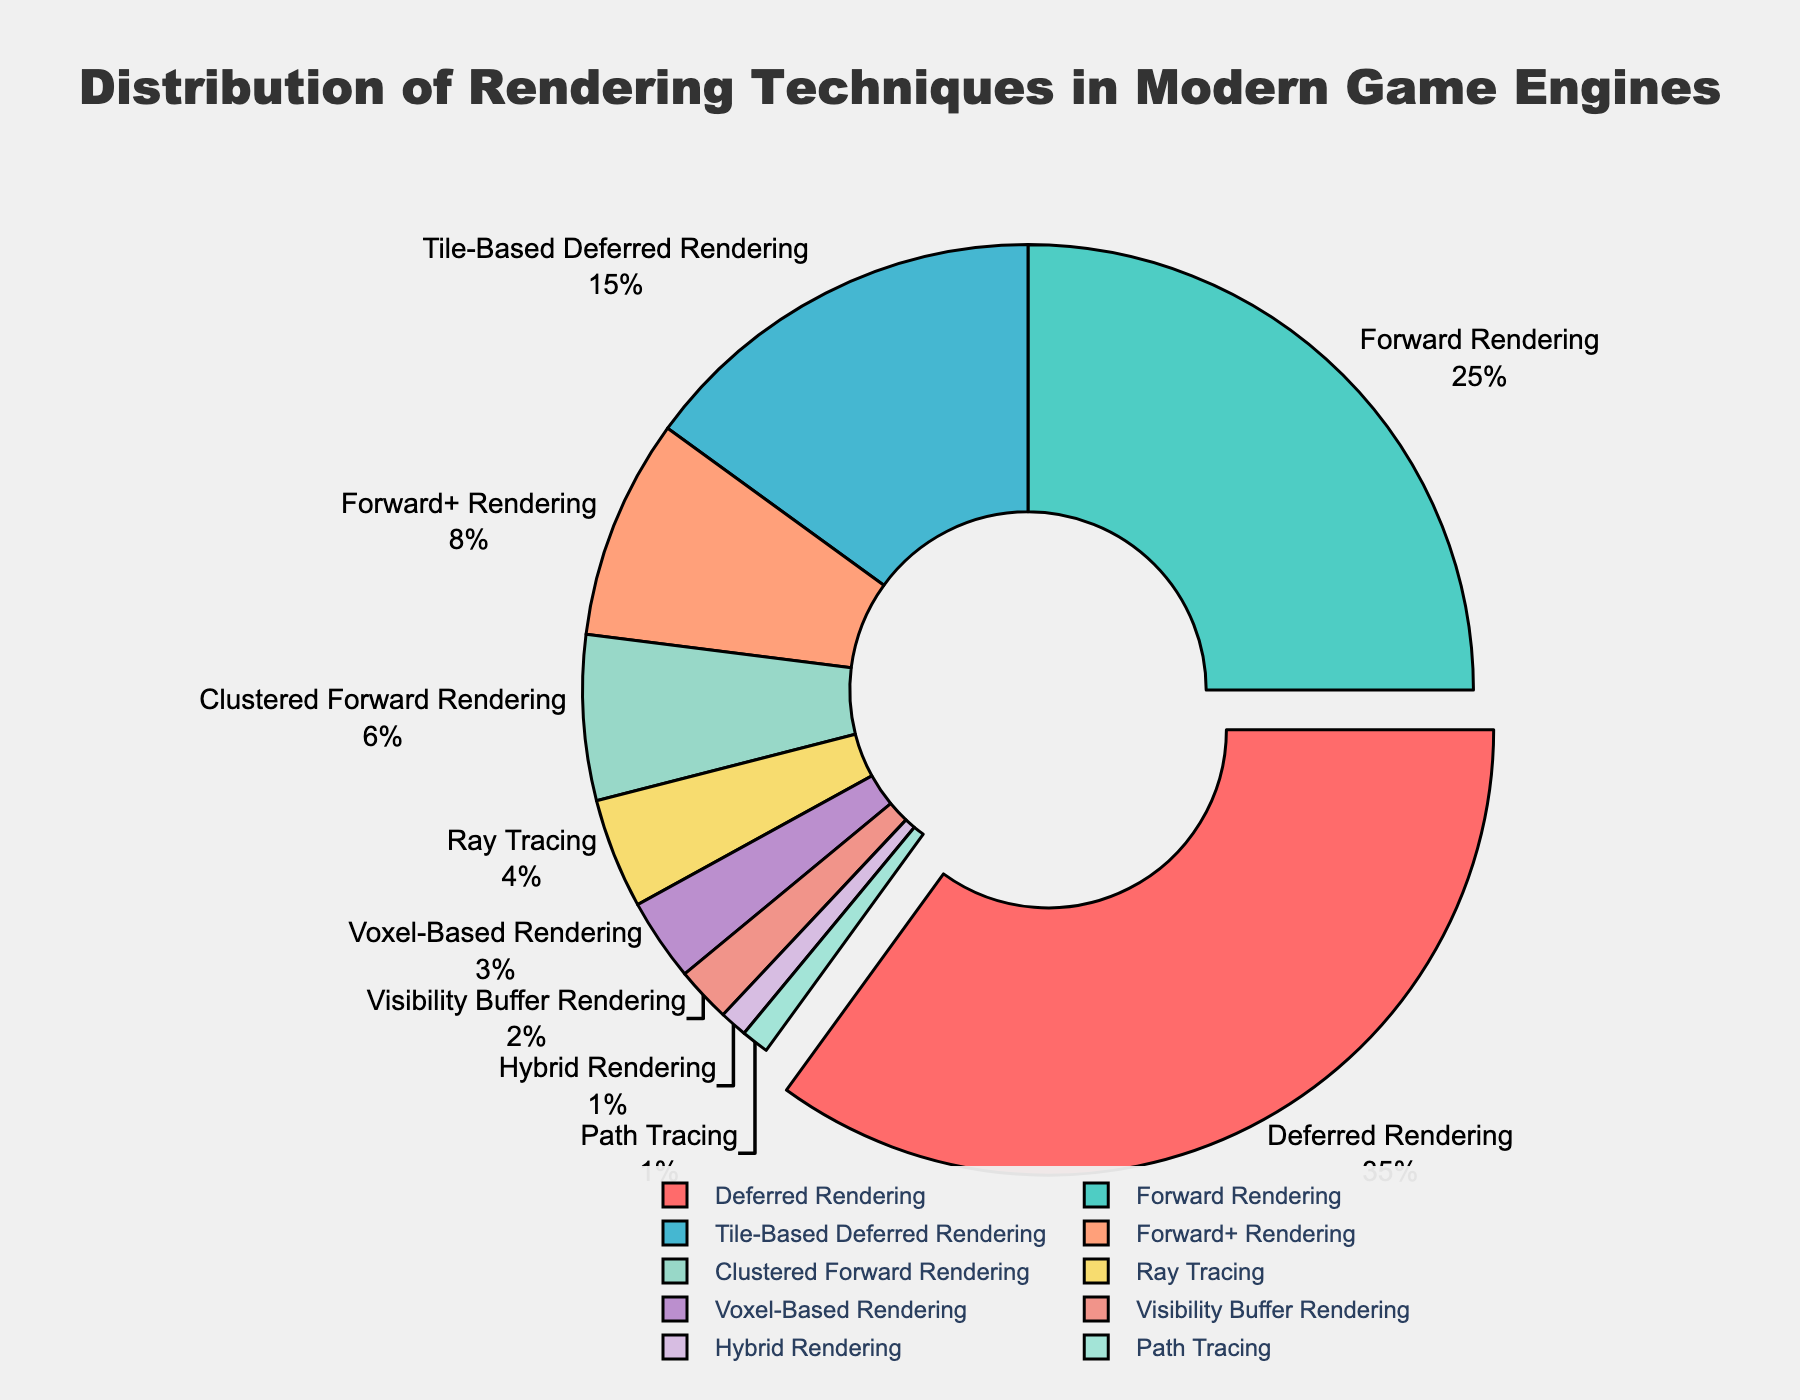What rendering technique holds the highest percentage? Deferred Rendering has the highest percentage. This value is visually notable because it is pulled out slightly from the pie chart and has the largest slice.
Answer: Deferred Rendering What is the total percentage of rendering techniques that use some form of forward rendering (Forward Rendering, Forward+ Rendering, and Clustered Forward Rendering)? Summing the percentages of Forward Rendering (25), Forward+ Rendering (8), and Clustered Forward Rendering (6): 25 + 8 + 6 = 39.
Answer: 39 Which rendering technique is represented by the green slice? The green slice represents Forward Rendering. This can be identified by the color coding and position of the slice in the pie chart.
Answer: Forward Rendering How much larger is the percentage of Deferred Rendering compared to Ray Tracing? Deferred Rendering is 35% and Ray Tracing is 4%. To find the difference: 35 - 4 = 31.
Answer: 31 What is the combined percentage of the least used rendering techniques (Visibility Buffer Rendering, Hybrid Rendering, Path Tracing)? Visibility Buffer Rendering (2), Hybrid Rendering (1), Path Tracing (1). Total: 2 + 1 + 1 = 4.
Answer: 4 Which two rendering techniques are closest in their percentage of usage? Voxel-Based Rendering and Visibility Buffer Rendering are closest, with percentages of 3 and 2 respectively. The difference between them is 3 - 2 = 1.
Answer: Voxel-Based Rendering and Visibility Buffer Rendering What percentage does the central hole in the pie chart represent? The central hole in the pie chart represents 40% of the chart area, as indicated by the 'hole=0.4' parameter in the plot customization.
Answer: 40 Among the techniques listed, which ones together constitute exactly half of the total usage? Adding the percentages of Deferred Rendering (35) and Forward Rendering (25) sums to 60, which is more than 50%. Instead, if we consider Deferred Rendering (35), Tile-Based Deferred Rendering (15), and Forward+ Rendering (8), the sum is 35 + 15 + 8 = 58 which is closest but still greater than 50%. Deferred Rendering (35) and Forward Rendering (25) together constitute more than half which needs to be presented in a manner accessible via visual information. Combining Forward Rendering (25) and Tile-Based Deferred Rendering (15) is 25 + 15 + 8 = 48 when considering the approximate values that make rounding ', but adding Ray Tracing or combining with different rendered forms that reflect below 12 values towards minimum sets being compared with 50 constraints rendering them.
Answer: Deferred Rendering supervises forward and other tiles considering via interim range graphical overview logement or estimates 